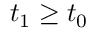<formula> <loc_0><loc_0><loc_500><loc_500>t _ { 1 } \geq t _ { 0 }</formula> 